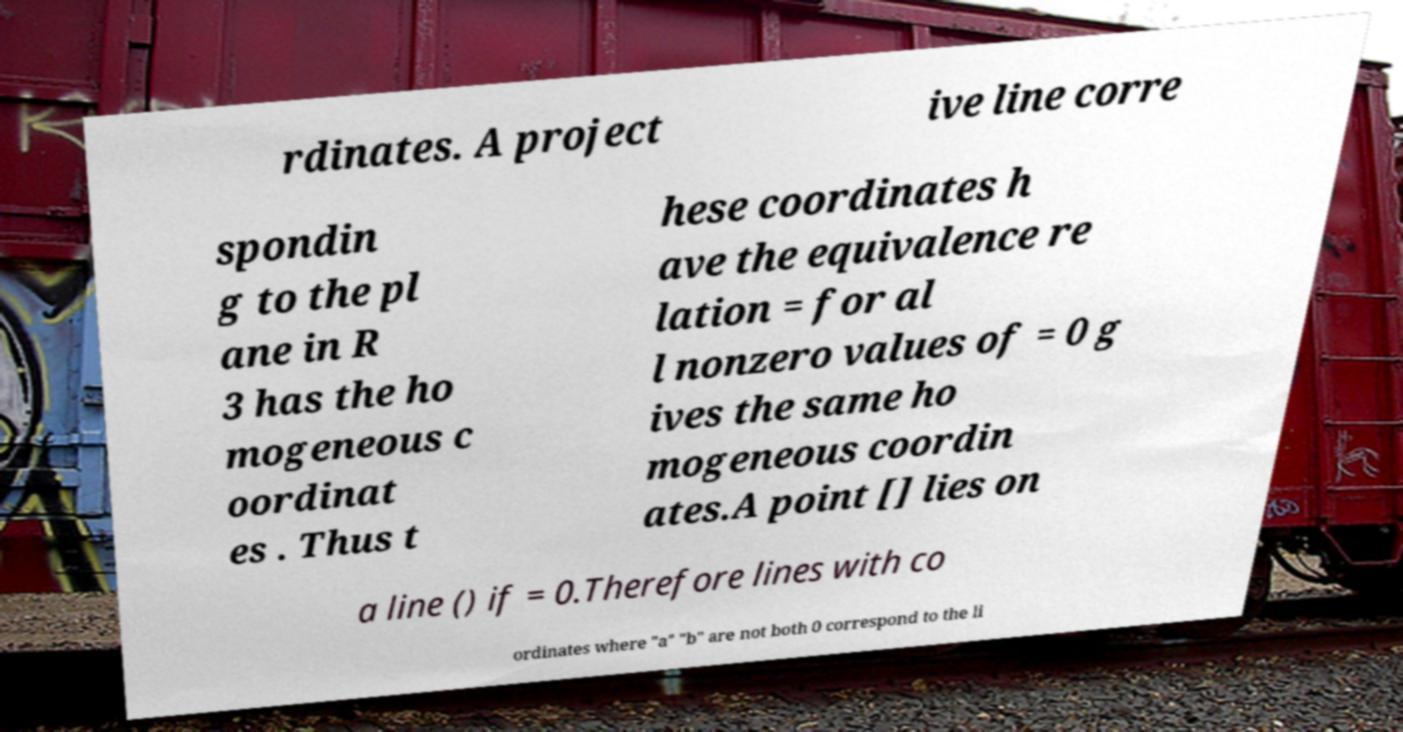Please identify and transcribe the text found in this image. rdinates. A project ive line corre spondin g to the pl ane in R 3 has the ho mogeneous c oordinat es . Thus t hese coordinates h ave the equivalence re lation = for al l nonzero values of = 0 g ives the same ho mogeneous coordin ates.A point [] lies on a line () if = 0.Therefore lines with co ordinates where "a" "b" are not both 0 correspond to the li 